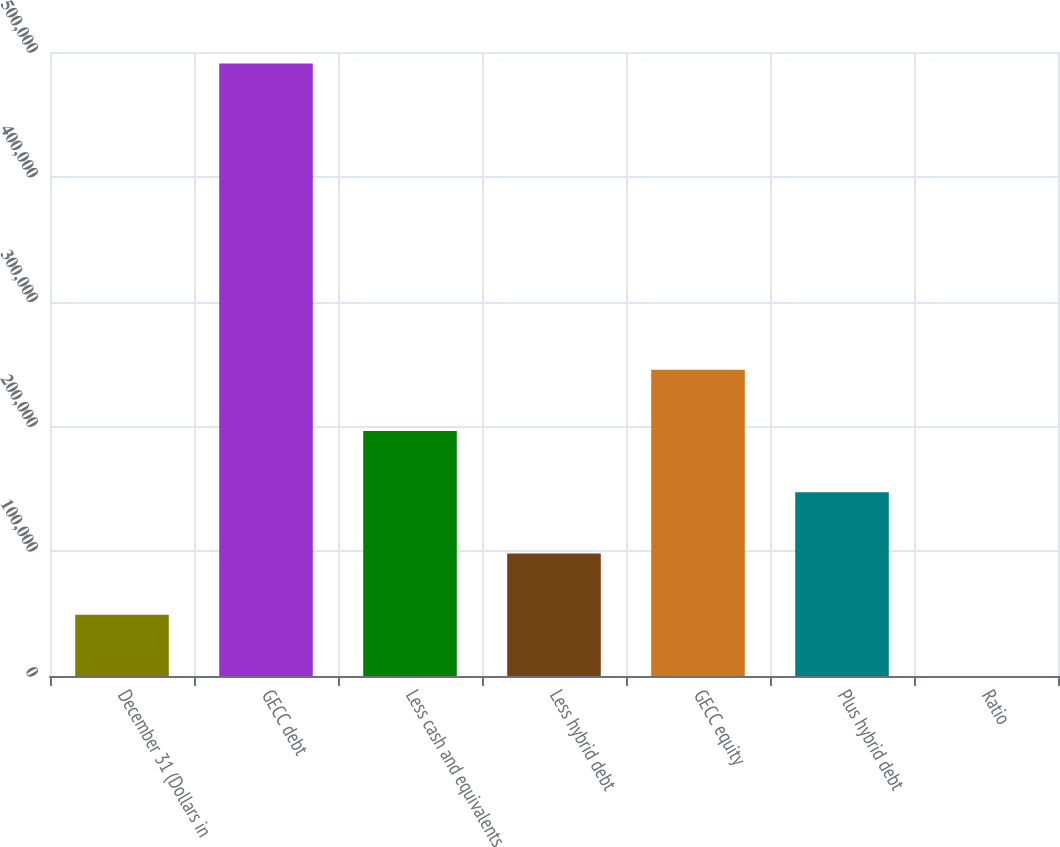Convert chart. <chart><loc_0><loc_0><loc_500><loc_500><bar_chart><fcel>December 31 (Dollars in<fcel>GECC debt<fcel>Less cash and equivalents<fcel>Less hybrid debt<fcel>GECC equity<fcel>Plus hybrid debt<fcel>Ratio<nl><fcel>49075.3<fcel>490707<fcel>196286<fcel>98145.5<fcel>245356<fcel>147216<fcel>5.17<nl></chart> 